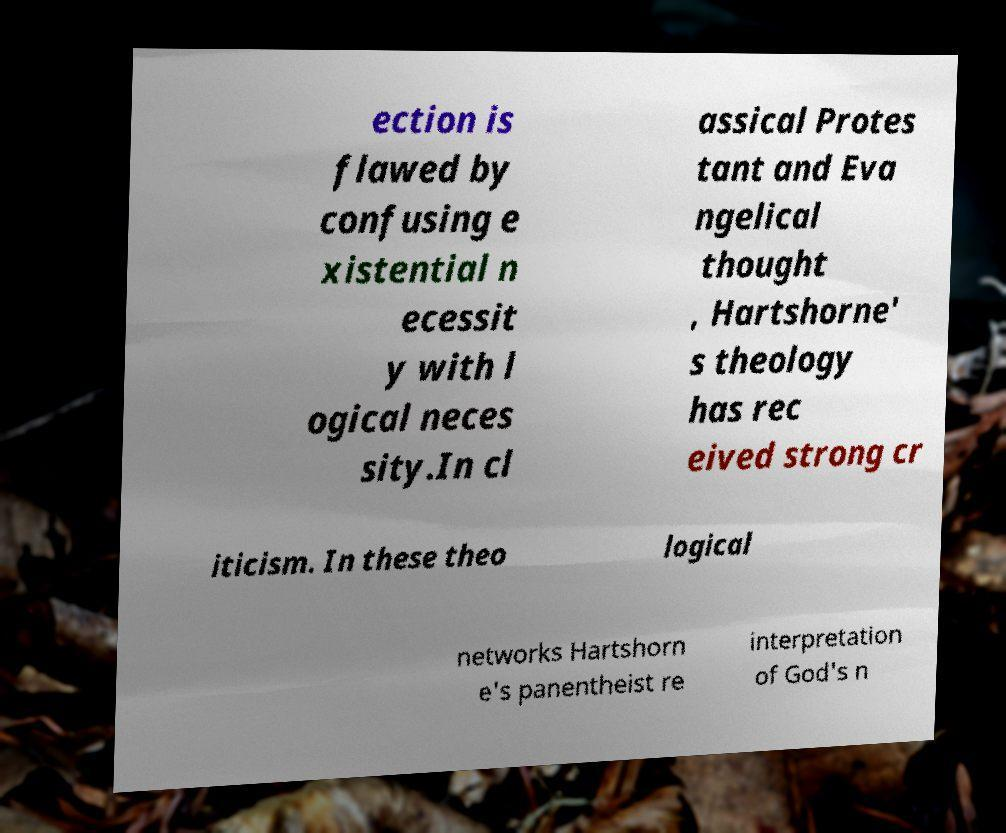Please read and relay the text visible in this image. What does it say? ection is flawed by confusing e xistential n ecessit y with l ogical neces sity.In cl assical Protes tant and Eva ngelical thought , Hartshorne' s theology has rec eived strong cr iticism. In these theo logical networks Hartshorn e's panentheist re interpretation of God's n 